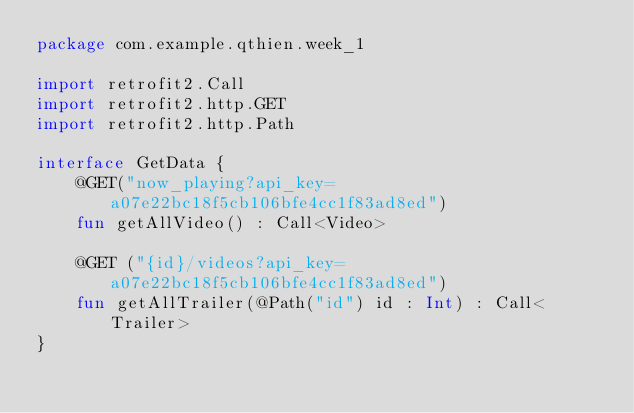<code> <loc_0><loc_0><loc_500><loc_500><_Kotlin_>package com.example.qthien.week_1

import retrofit2.Call
import retrofit2.http.GET
import retrofit2.http.Path

interface GetData {
    @GET("now_playing?api_key=a07e22bc18f5cb106bfe4cc1f83ad8ed")
    fun getAllVideo() : Call<Video>

    @GET ("{id}/videos?api_key=a07e22bc18f5cb106bfe4cc1f83ad8ed")
    fun getAllTrailer(@Path("id") id : Int) : Call<Trailer>
}</code> 